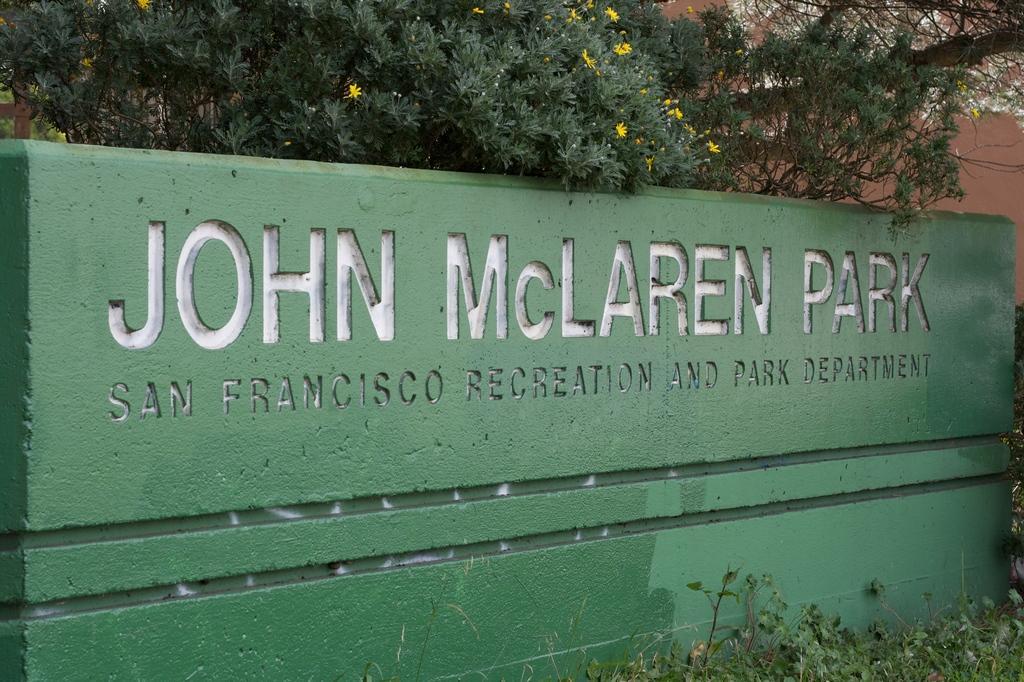Describe this image in one or two sentences. Here we can see a board and there are plants. In the background we can see trees, flowers, and a wall. 